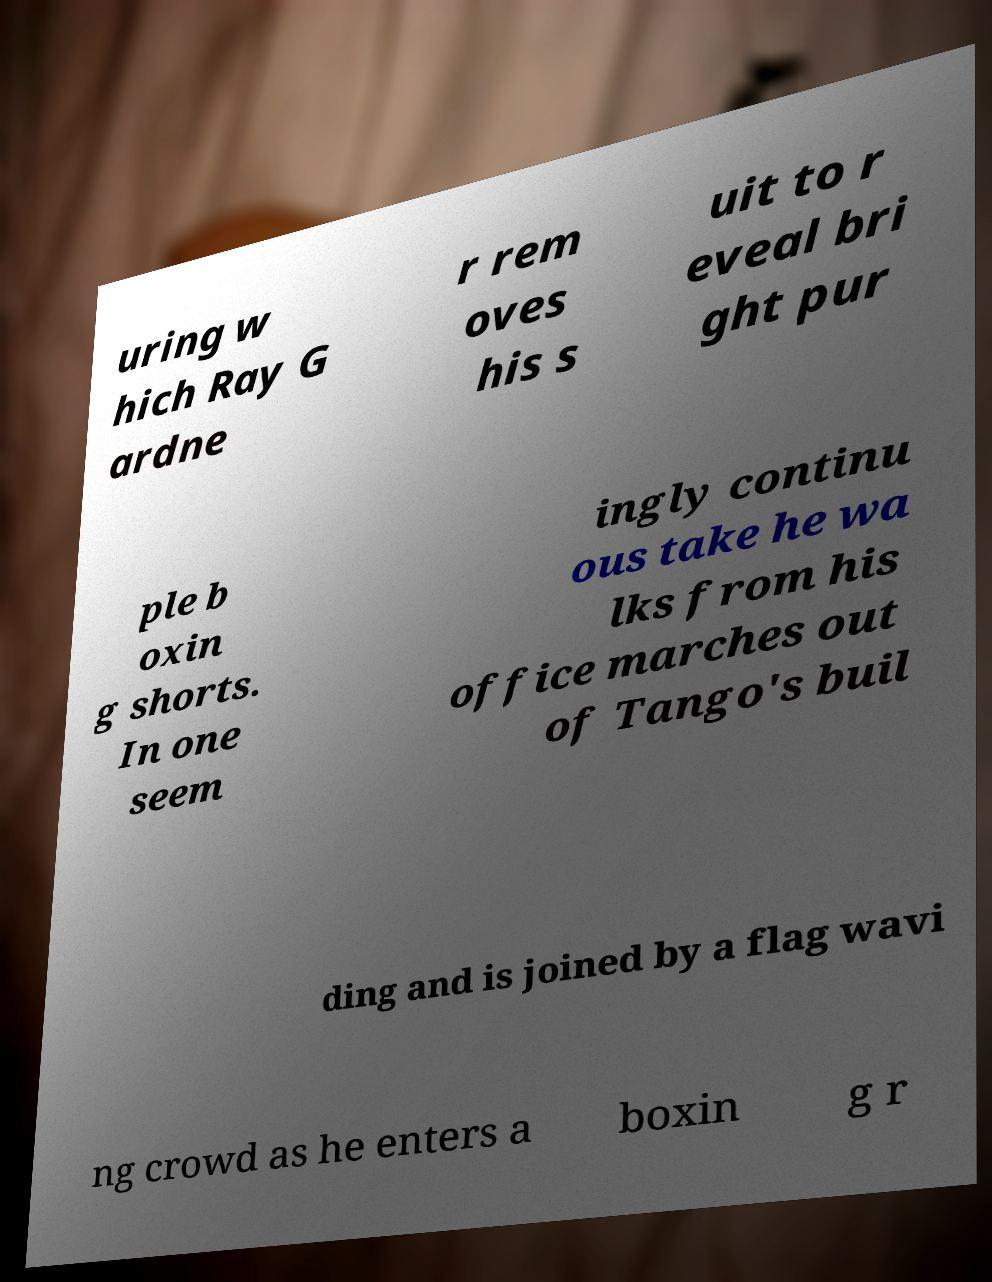I need the written content from this picture converted into text. Can you do that? uring w hich Ray G ardne r rem oves his s uit to r eveal bri ght pur ple b oxin g shorts. In one seem ingly continu ous take he wa lks from his office marches out of Tango's buil ding and is joined by a flag wavi ng crowd as he enters a boxin g r 